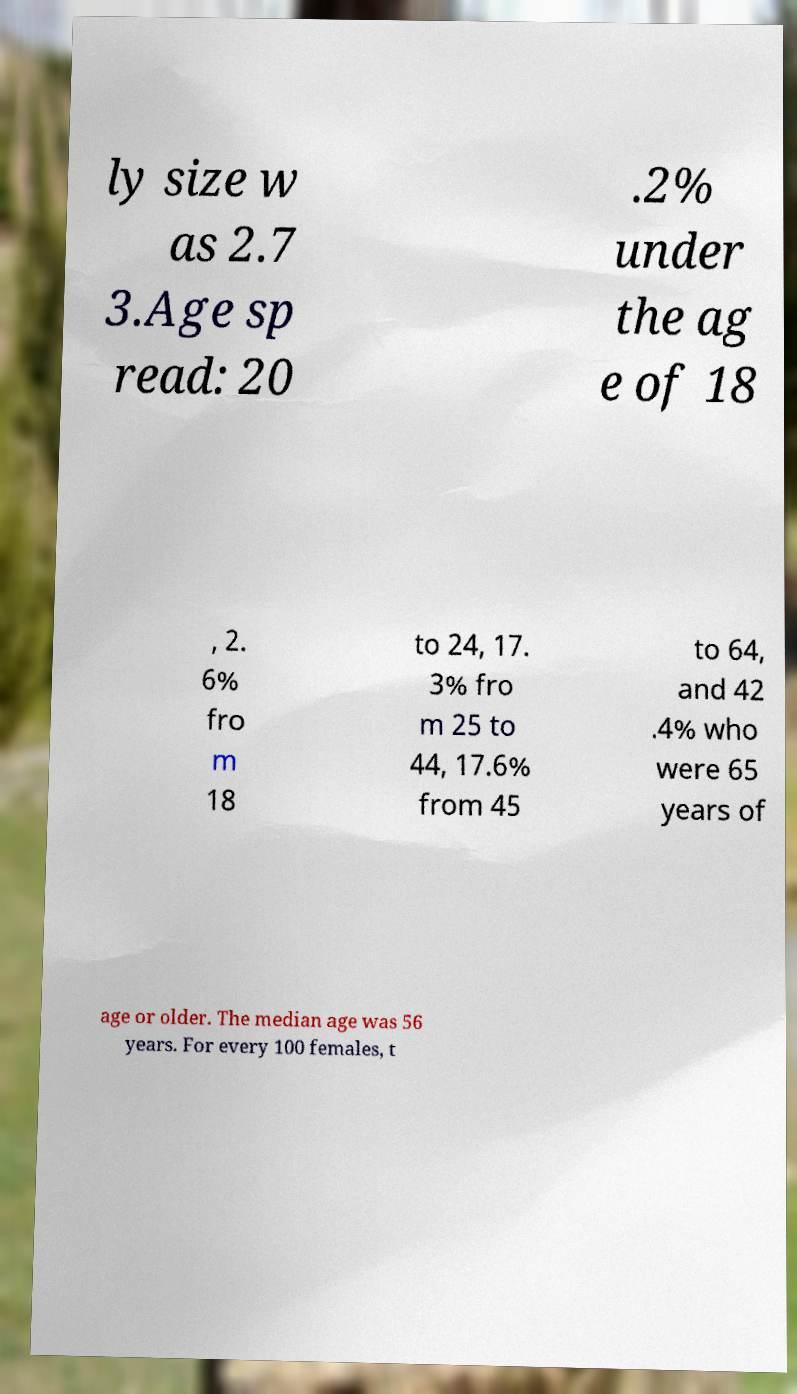Can you read and provide the text displayed in the image?This photo seems to have some interesting text. Can you extract and type it out for me? ly size w as 2.7 3.Age sp read: 20 .2% under the ag e of 18 , 2. 6% fro m 18 to 24, 17. 3% fro m 25 to 44, 17.6% from 45 to 64, and 42 .4% who were 65 years of age or older. The median age was 56 years. For every 100 females, t 